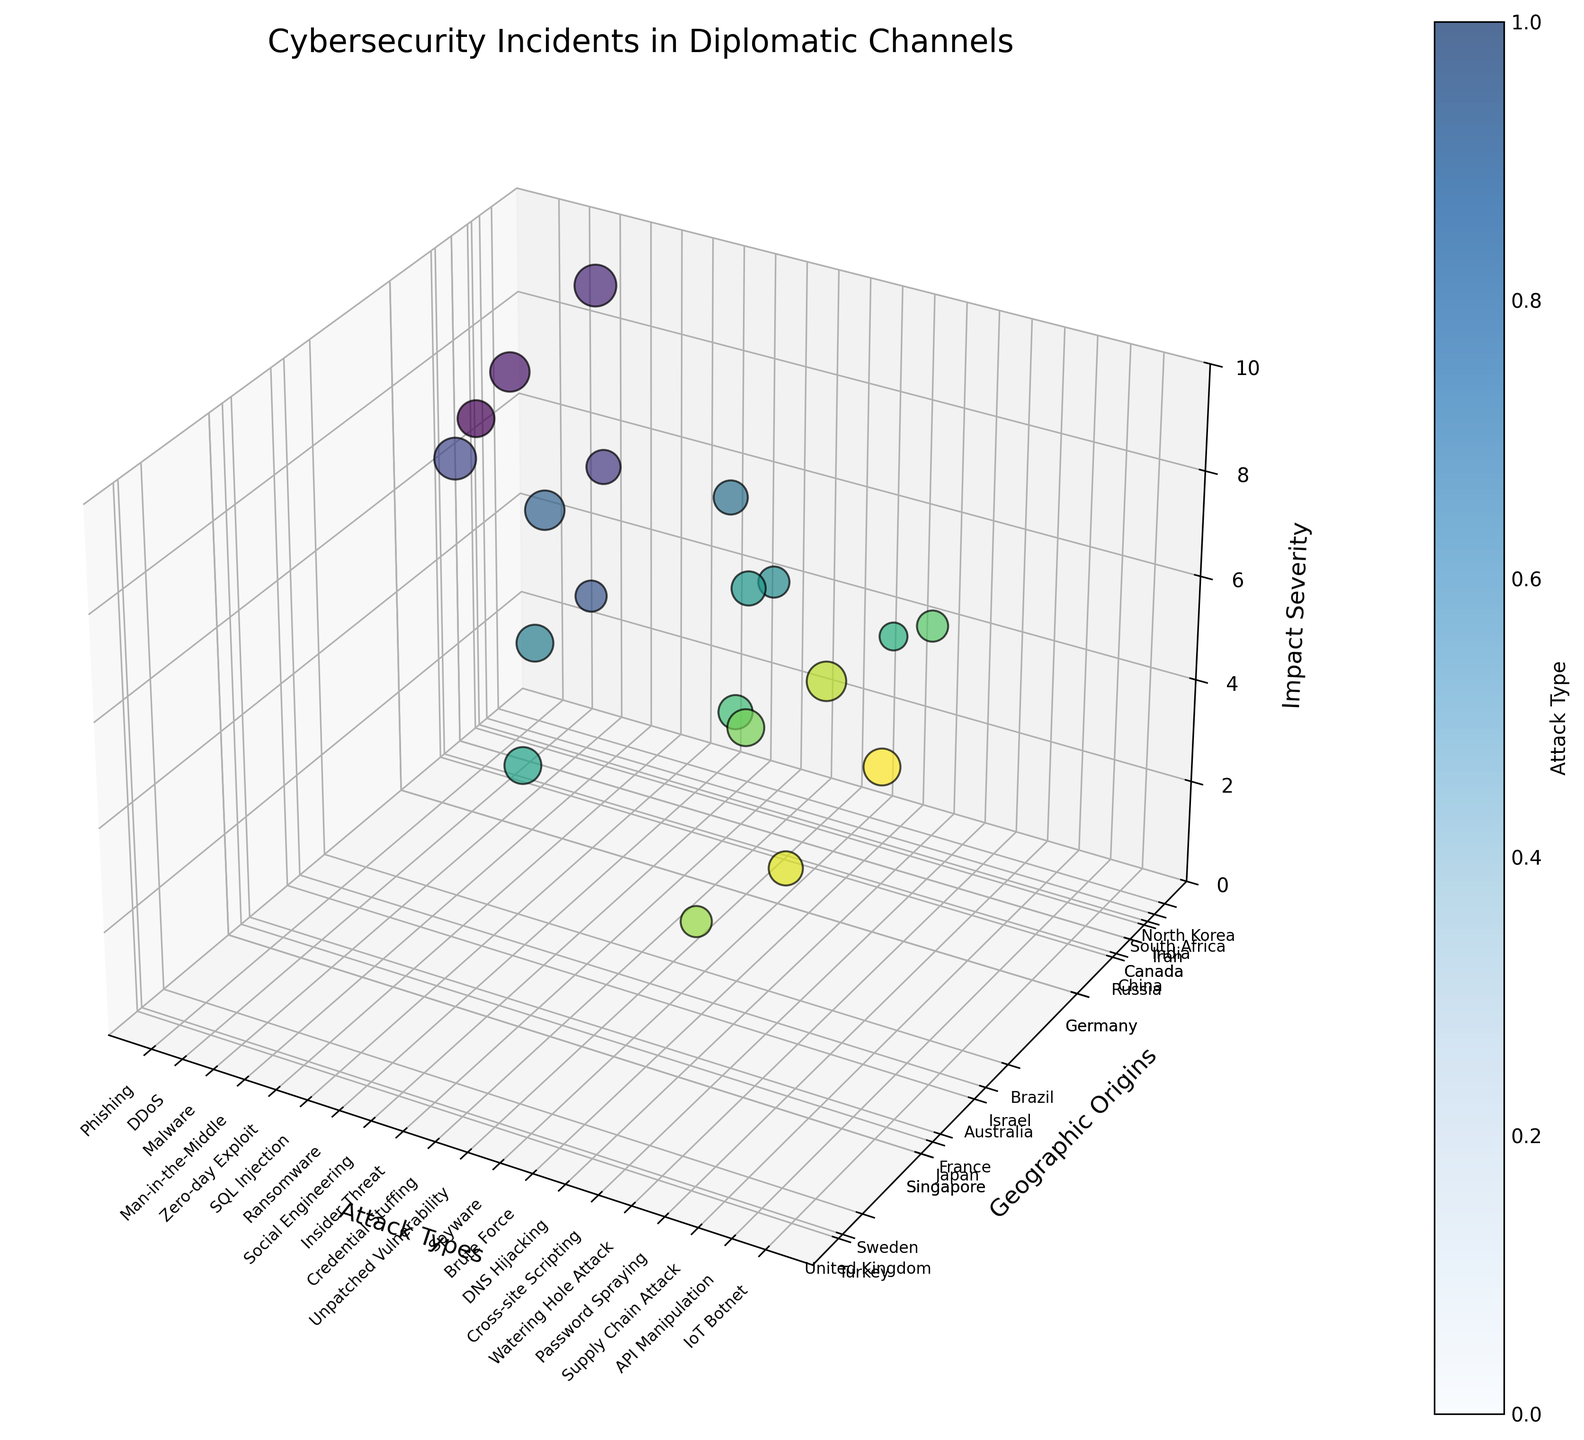What is the title of the figure? The title of the figure is displayed at the top of the plot. It is written in larger font size to be easily noticeable.
Answer: Cybersecurity Incidents in Diplomatic Channels How many types of cybersecurity attacks are plotted? The number of different cybersecurity attack types can be counted by looking at the x-axis and checking the distinct attack types provided.
Answer: 20 Which geographical origin has the highest impact severity and what is the attack type? To find this, look for the data point with the highest z-value (impact severity) and note its corresponding y-value (geographical origin) and x-value (attack type).
Answer: North Korea, Malware What is the average impact severity of the attacks? Sum all the impact severity values and divide by the number of data points. \((7+8+9+6+9+5+8+6+7+5+6+7+4+6+5+7+5+8+6+7) / 20 = 139 / 20\)
Answer: 6.95 Which attack type has an impact severity of 4, and what is its geographic origin? Identify the point where the z-value is 4 and check the corresponding x-value (attack type) and y-value (geographical origin).
Answer: Brute Force, South Africa What is the range of impact severities observed in the plot? Identify the minimum and maximum z-values (impact severities) in the scatter plot to determine the range.
Answer: 4 to 9 Which three geographical origins appear most frequently in the plot? Count the occurrences of each geographical origin label on the y-axis and identify the top three with the highest frequencies.
Answer: Russia, United States, India How does the impact severity of DDoS attacks from China compare to that of Ransomware attacks from Brazil? Check the impact severity values for the specified attack types and compare those values.
Answer: DDoS (8) is equal to Ransomware (8) Which geographic origin is associated with the attack type 'Zero-day Exploit' and what is its impact severity? Look for the specific attack type on the x-axis, note its geographic origin on the y-axis, and its impact severity on the z-axis.
Answer: Israel, 9 Are there any attack types with the same impact severity but originating from different geographic locations? If so, name them. Scan the plot to find any data points with the same z-value (impact severity) but different y-values (geographic origins).
Answer: Yes, Phishing (Russia) and Insider Threat (France) both have severity 7; IoT Botnet (Singapore) and Spyware (Turkey) both have severity 7 